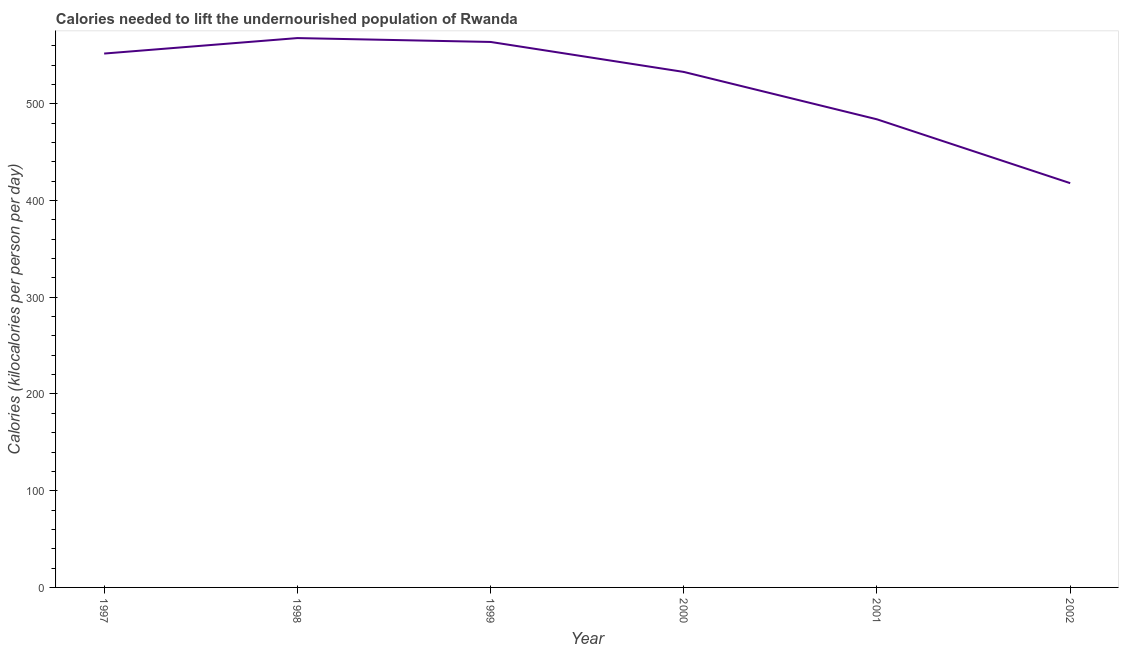What is the depth of food deficit in 2002?
Ensure brevity in your answer.  418. Across all years, what is the maximum depth of food deficit?
Your answer should be compact. 568. Across all years, what is the minimum depth of food deficit?
Your answer should be very brief. 418. In which year was the depth of food deficit maximum?
Provide a succinct answer. 1998. In which year was the depth of food deficit minimum?
Make the answer very short. 2002. What is the sum of the depth of food deficit?
Your response must be concise. 3119. What is the difference between the depth of food deficit in 1998 and 1999?
Keep it short and to the point. 4. What is the average depth of food deficit per year?
Provide a succinct answer. 519.83. What is the median depth of food deficit?
Offer a very short reply. 542.5. What is the ratio of the depth of food deficit in 1998 to that in 2002?
Your answer should be very brief. 1.36. Is the difference between the depth of food deficit in 1999 and 2001 greater than the difference between any two years?
Keep it short and to the point. No. What is the difference between the highest and the second highest depth of food deficit?
Ensure brevity in your answer.  4. Is the sum of the depth of food deficit in 2000 and 2001 greater than the maximum depth of food deficit across all years?
Offer a terse response. Yes. What is the difference between the highest and the lowest depth of food deficit?
Provide a short and direct response. 150. In how many years, is the depth of food deficit greater than the average depth of food deficit taken over all years?
Keep it short and to the point. 4. How many lines are there?
Keep it short and to the point. 1. Are the values on the major ticks of Y-axis written in scientific E-notation?
Provide a succinct answer. No. Does the graph contain grids?
Provide a succinct answer. No. What is the title of the graph?
Keep it short and to the point. Calories needed to lift the undernourished population of Rwanda. What is the label or title of the X-axis?
Offer a very short reply. Year. What is the label or title of the Y-axis?
Provide a short and direct response. Calories (kilocalories per person per day). What is the Calories (kilocalories per person per day) in 1997?
Your response must be concise. 552. What is the Calories (kilocalories per person per day) of 1998?
Ensure brevity in your answer.  568. What is the Calories (kilocalories per person per day) in 1999?
Provide a succinct answer. 564. What is the Calories (kilocalories per person per day) in 2000?
Provide a succinct answer. 533. What is the Calories (kilocalories per person per day) of 2001?
Provide a short and direct response. 484. What is the Calories (kilocalories per person per day) of 2002?
Keep it short and to the point. 418. What is the difference between the Calories (kilocalories per person per day) in 1997 and 1999?
Give a very brief answer. -12. What is the difference between the Calories (kilocalories per person per day) in 1997 and 2000?
Offer a very short reply. 19. What is the difference between the Calories (kilocalories per person per day) in 1997 and 2001?
Keep it short and to the point. 68. What is the difference between the Calories (kilocalories per person per day) in 1997 and 2002?
Make the answer very short. 134. What is the difference between the Calories (kilocalories per person per day) in 1998 and 1999?
Give a very brief answer. 4. What is the difference between the Calories (kilocalories per person per day) in 1998 and 2002?
Provide a short and direct response. 150. What is the difference between the Calories (kilocalories per person per day) in 1999 and 2000?
Keep it short and to the point. 31. What is the difference between the Calories (kilocalories per person per day) in 1999 and 2002?
Provide a short and direct response. 146. What is the difference between the Calories (kilocalories per person per day) in 2000 and 2001?
Your response must be concise. 49. What is the difference between the Calories (kilocalories per person per day) in 2000 and 2002?
Keep it short and to the point. 115. What is the ratio of the Calories (kilocalories per person per day) in 1997 to that in 1998?
Give a very brief answer. 0.97. What is the ratio of the Calories (kilocalories per person per day) in 1997 to that in 1999?
Provide a succinct answer. 0.98. What is the ratio of the Calories (kilocalories per person per day) in 1997 to that in 2000?
Provide a short and direct response. 1.04. What is the ratio of the Calories (kilocalories per person per day) in 1997 to that in 2001?
Your response must be concise. 1.14. What is the ratio of the Calories (kilocalories per person per day) in 1997 to that in 2002?
Your response must be concise. 1.32. What is the ratio of the Calories (kilocalories per person per day) in 1998 to that in 1999?
Give a very brief answer. 1.01. What is the ratio of the Calories (kilocalories per person per day) in 1998 to that in 2000?
Give a very brief answer. 1.07. What is the ratio of the Calories (kilocalories per person per day) in 1998 to that in 2001?
Offer a very short reply. 1.17. What is the ratio of the Calories (kilocalories per person per day) in 1998 to that in 2002?
Offer a very short reply. 1.36. What is the ratio of the Calories (kilocalories per person per day) in 1999 to that in 2000?
Your answer should be very brief. 1.06. What is the ratio of the Calories (kilocalories per person per day) in 1999 to that in 2001?
Your answer should be compact. 1.17. What is the ratio of the Calories (kilocalories per person per day) in 1999 to that in 2002?
Provide a succinct answer. 1.35. What is the ratio of the Calories (kilocalories per person per day) in 2000 to that in 2001?
Give a very brief answer. 1.1. What is the ratio of the Calories (kilocalories per person per day) in 2000 to that in 2002?
Provide a succinct answer. 1.27. What is the ratio of the Calories (kilocalories per person per day) in 2001 to that in 2002?
Provide a succinct answer. 1.16. 